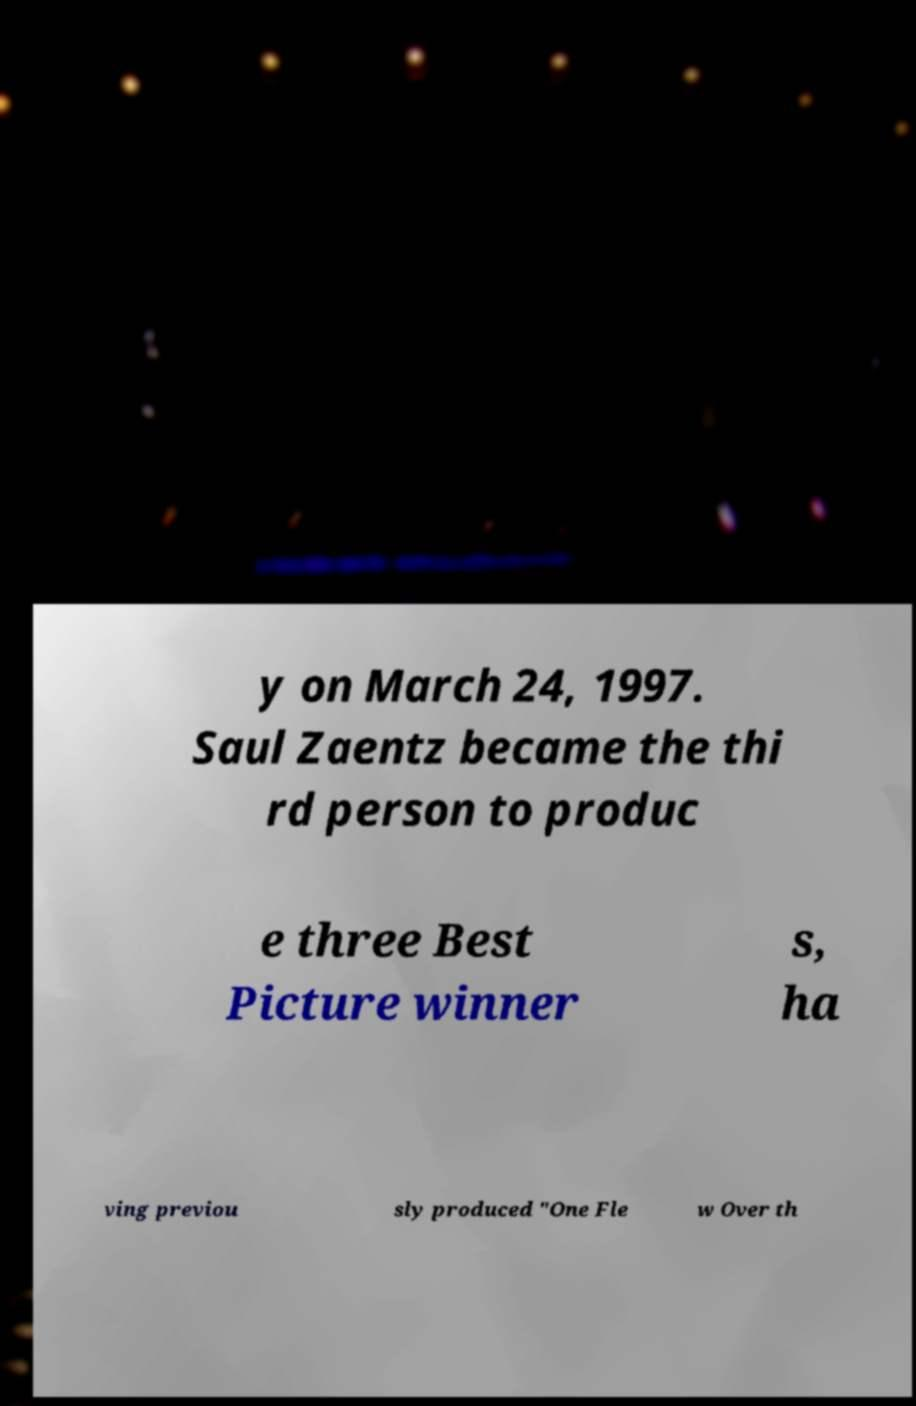What messages or text are displayed in this image? I need them in a readable, typed format. y on March 24, 1997. Saul Zaentz became the thi rd person to produc e three Best Picture winner s, ha ving previou sly produced "One Fle w Over th 